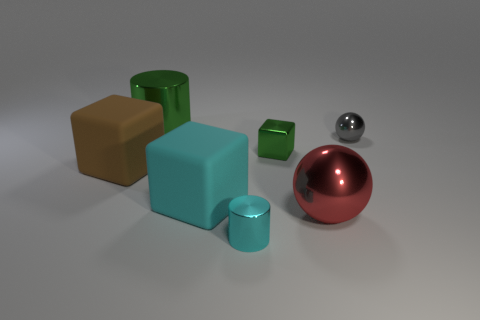Add 2 large cyan things. How many objects exist? 9 Subtract all balls. How many objects are left? 5 Add 2 blocks. How many blocks exist? 5 Subtract 1 green cubes. How many objects are left? 6 Subtract all tiny shiny balls. Subtract all cyan metallic things. How many objects are left? 5 Add 5 big brown matte blocks. How many big brown matte blocks are left? 6 